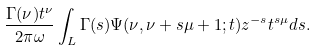Convert formula to latex. <formula><loc_0><loc_0><loc_500><loc_500>\frac { \Gamma ( \nu ) t ^ { \nu } } { 2 \pi \omega } \int _ { L } \Gamma ( s ) \Psi ( \nu , \nu + s \mu + 1 ; t ) z ^ { - s } t ^ { s \mu } d s .</formula> 